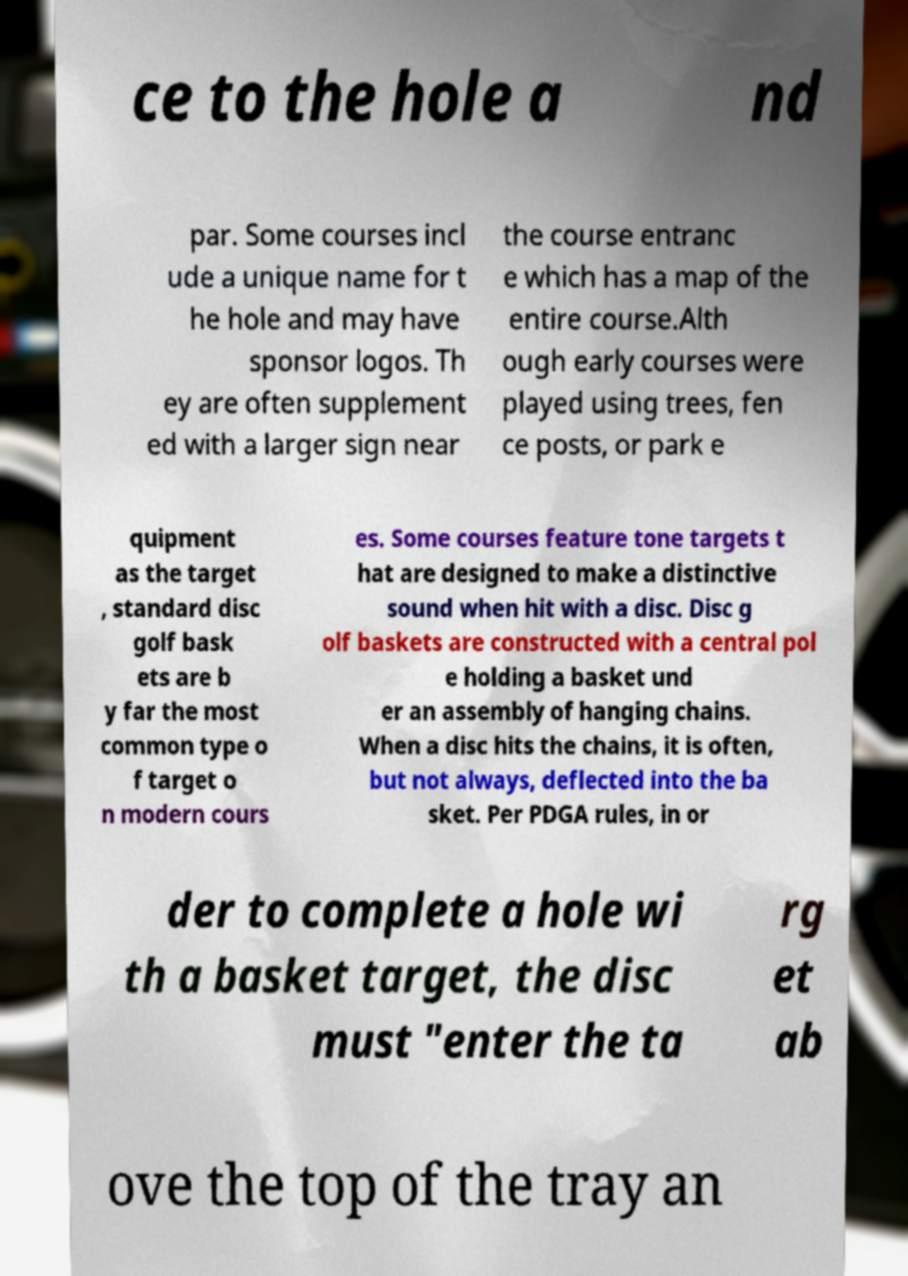Can you read and provide the text displayed in the image?This photo seems to have some interesting text. Can you extract and type it out for me? ce to the hole a nd par. Some courses incl ude a unique name for t he hole and may have sponsor logos. Th ey are often supplement ed with a larger sign near the course entranc e which has a map of the entire course.Alth ough early courses were played using trees, fen ce posts, or park e quipment as the target , standard disc golf bask ets are b y far the most common type o f target o n modern cours es. Some courses feature tone targets t hat are designed to make a distinctive sound when hit with a disc. Disc g olf baskets are constructed with a central pol e holding a basket und er an assembly of hanging chains. When a disc hits the chains, it is often, but not always, deflected into the ba sket. Per PDGA rules, in or der to complete a hole wi th a basket target, the disc must "enter the ta rg et ab ove the top of the tray an 